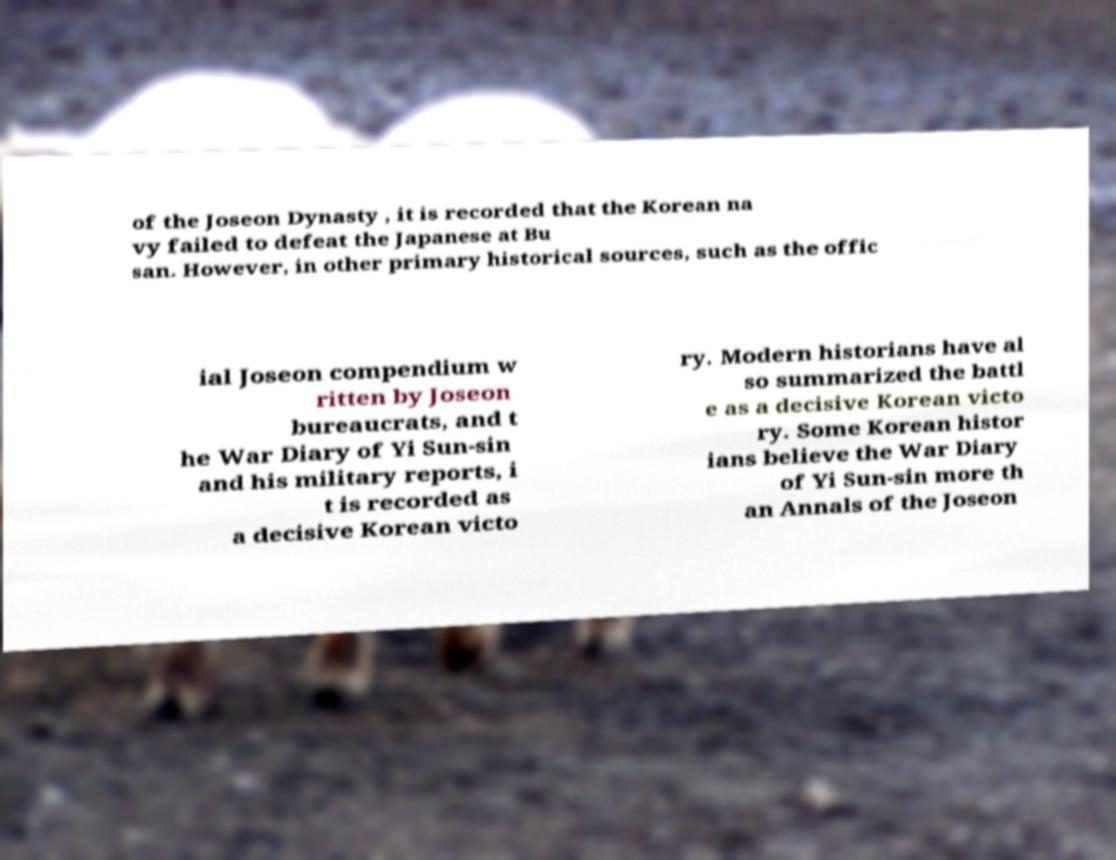Can you accurately transcribe the text from the provided image for me? of the Joseon Dynasty , it is recorded that the Korean na vy failed to defeat the Japanese at Bu san. However, in other primary historical sources, such as the offic ial Joseon compendium w ritten by Joseon bureaucrats, and t he War Diary of Yi Sun-sin and his military reports, i t is recorded as a decisive Korean victo ry. Modern historians have al so summarized the battl e as a decisive Korean victo ry. Some Korean histor ians believe the War Diary of Yi Sun-sin more th an Annals of the Joseon 